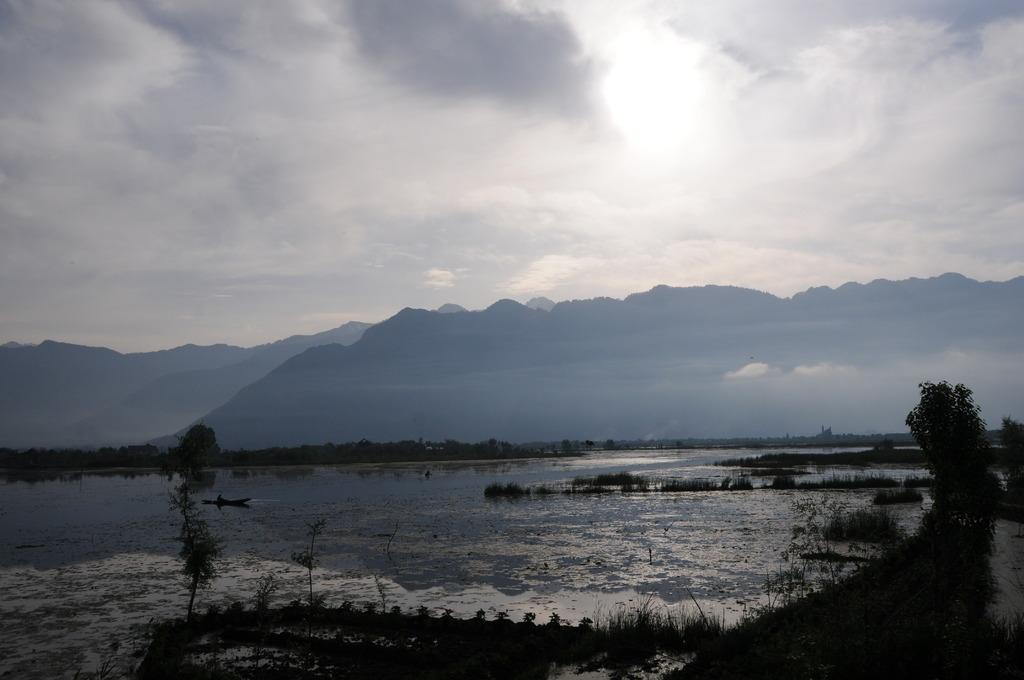What type of natural feature is present in the picture? There is a river in the picture. What can be seen in the middle of the picture? There are plants in the middle of the picture. What is visible in the background of the picture? There are hills and clouds in the sky in the background of the picture. What type of desk is visible in the picture? There is no desk present in the picture. Can you describe the haircut of the person in the picture? There are no people present in the picture, so it is not possible to describe a haircut. 